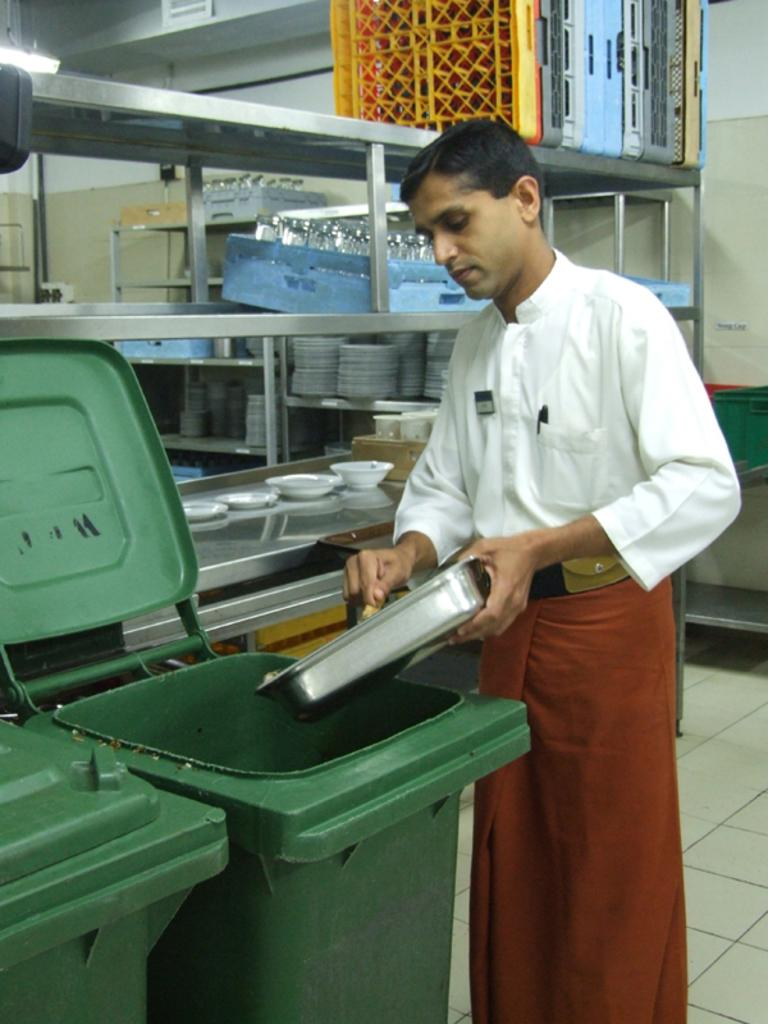What is the man in the image holding? The man is holding a tray in the image. What objects are in front of the man? There are dustbins in front of the man. What can be seen in the background of the image? There are plates, glasses, and trays in the background of the image. What type of lighting is present in the background of the image? There is a light in the background of the image. How many yams are on the tray the man is holding? There is no yam present on the tray or in the image. What type of snakes can be seen slithering on the floor in the image? There are no snakes visible in the image. 